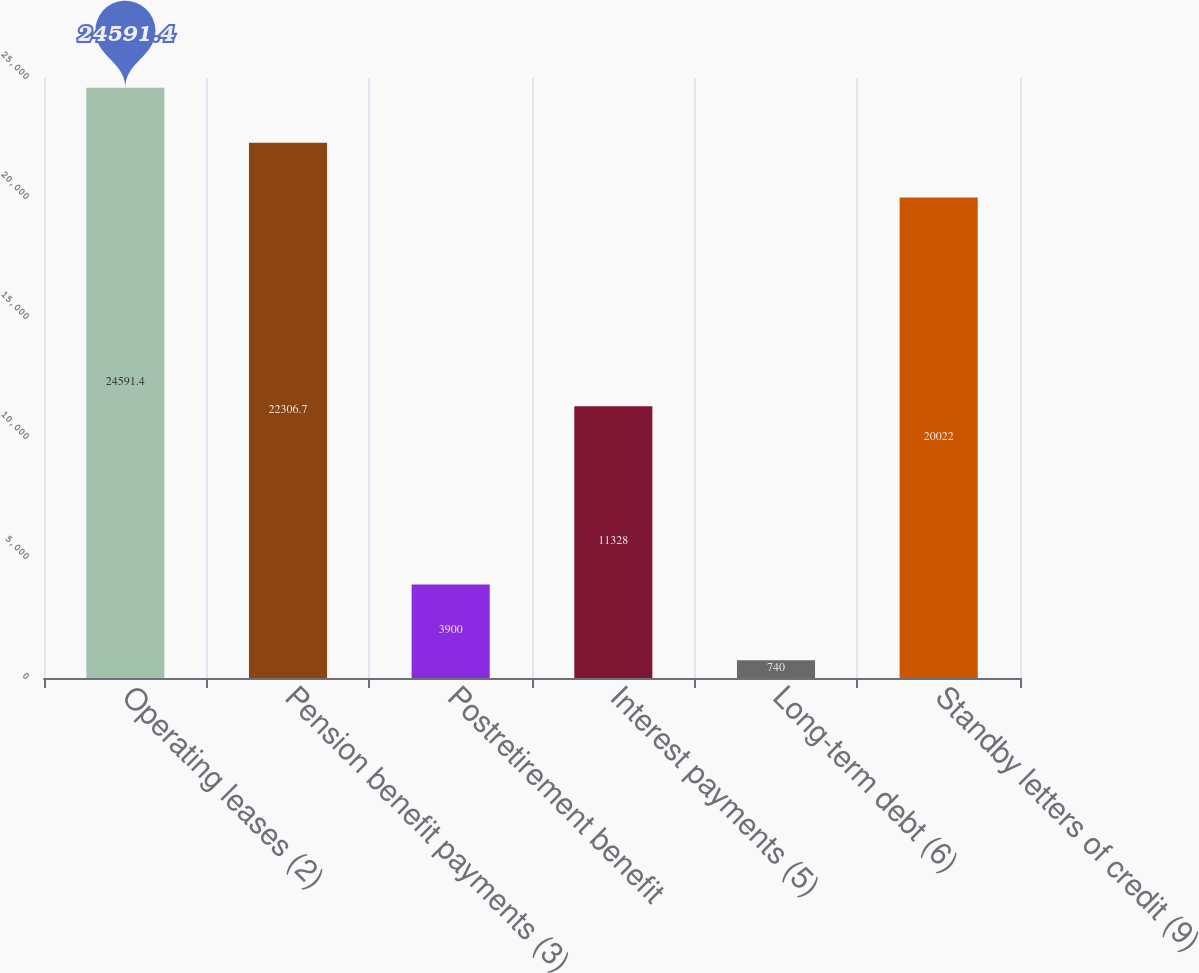Convert chart to OTSL. <chart><loc_0><loc_0><loc_500><loc_500><bar_chart><fcel>Operating leases (2)<fcel>Pension benefit payments (3)<fcel>Postretirement benefit<fcel>Interest payments (5)<fcel>Long-term debt (6)<fcel>Standby letters of credit (9)<nl><fcel>24591.4<fcel>22306.7<fcel>3900<fcel>11328<fcel>740<fcel>20022<nl></chart> 